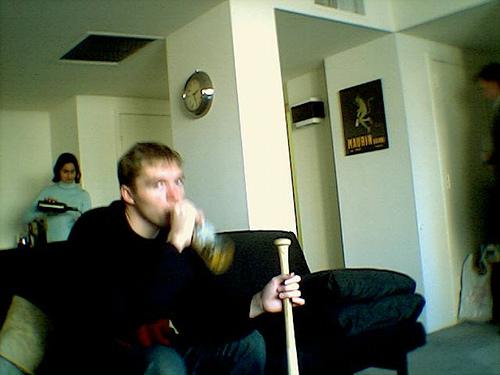How many kinds of alcohol are in this photo?
Be succinct. 2. What does the poster say?
Write a very short answer. Mandarin. What is the man holding is his left hand?
Write a very short answer. Baseball bat. 